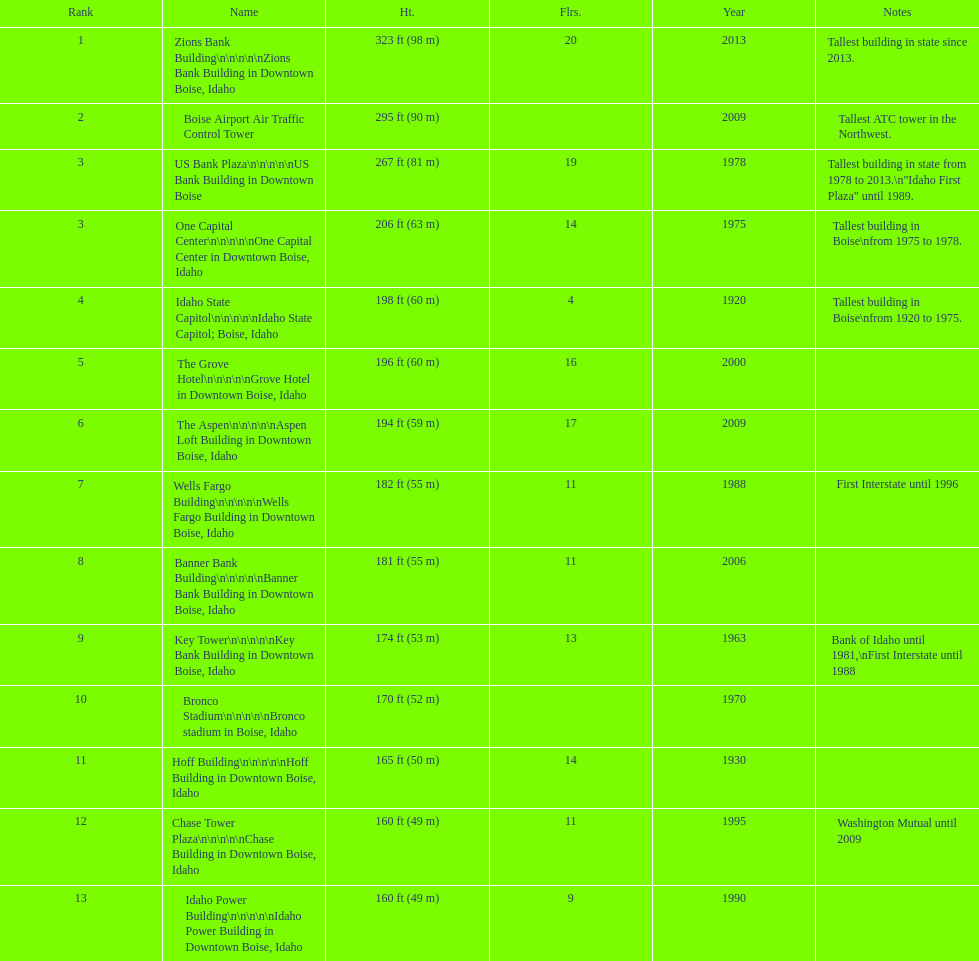What is the name of the last building on this chart? Idaho Power Building. 